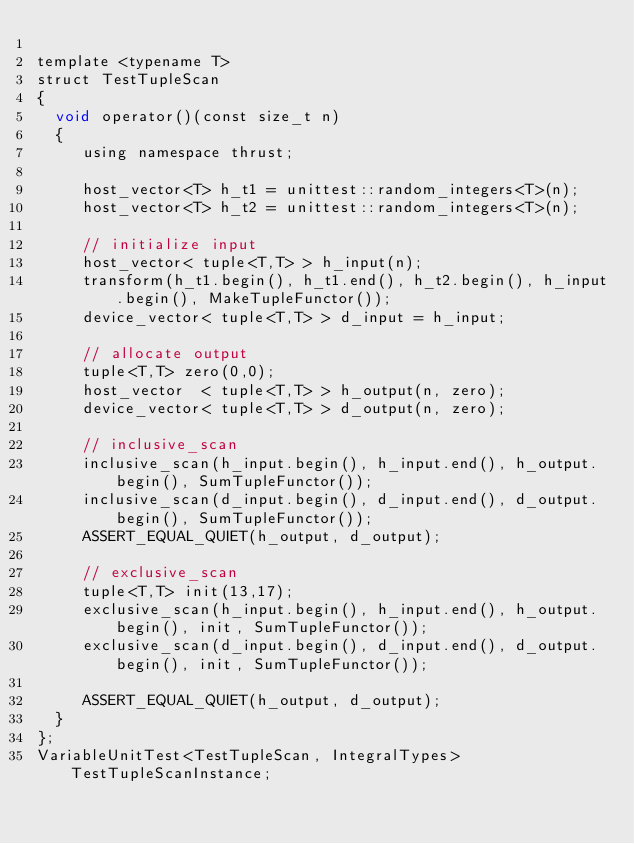Convert code to text. <code><loc_0><loc_0><loc_500><loc_500><_Cuda_>
template <typename T>
struct TestTupleScan
{
  void operator()(const size_t n)
  {
     using namespace thrust;

     host_vector<T> h_t1 = unittest::random_integers<T>(n);
     host_vector<T> h_t2 = unittest::random_integers<T>(n);

     // initialize input
     host_vector< tuple<T,T> > h_input(n);
     transform(h_t1.begin(), h_t1.end(), h_t2.begin(), h_input.begin(), MakeTupleFunctor());
     device_vector< tuple<T,T> > d_input = h_input;
     
     // allocate output
     tuple<T,T> zero(0,0);
     host_vector  < tuple<T,T> > h_output(n, zero);
     device_vector< tuple<T,T> > d_output(n, zero);

     // inclusive_scan
     inclusive_scan(h_input.begin(), h_input.end(), h_output.begin(), SumTupleFunctor());
     inclusive_scan(d_input.begin(), d_input.end(), d_output.begin(), SumTupleFunctor());
     ASSERT_EQUAL_QUIET(h_output, d_output);

     // exclusive_scan
     tuple<T,T> init(13,17);
     exclusive_scan(h_input.begin(), h_input.end(), h_output.begin(), init, SumTupleFunctor());
     exclusive_scan(d_input.begin(), d_input.end(), d_output.begin(), init, SumTupleFunctor());

     ASSERT_EQUAL_QUIET(h_output, d_output);
  }
};
VariableUnitTest<TestTupleScan, IntegralTypes> TestTupleScanInstance;

</code> 